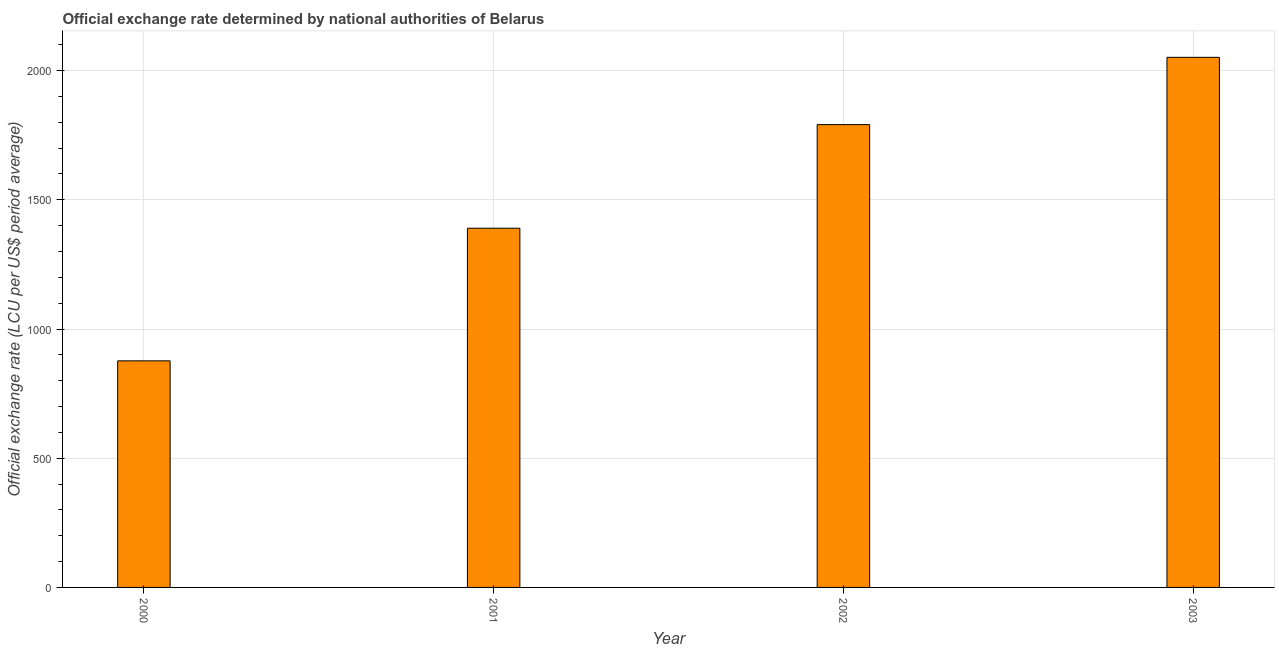Does the graph contain grids?
Offer a very short reply. Yes. What is the title of the graph?
Ensure brevity in your answer.  Official exchange rate determined by national authorities of Belarus. What is the label or title of the Y-axis?
Your answer should be very brief. Official exchange rate (LCU per US$ period average). What is the official exchange rate in 2003?
Your answer should be compact. 2051.27. Across all years, what is the maximum official exchange rate?
Provide a succinct answer. 2051.27. Across all years, what is the minimum official exchange rate?
Keep it short and to the point. 876.75. In which year was the official exchange rate maximum?
Your answer should be compact. 2003. In which year was the official exchange rate minimum?
Provide a succinct answer. 2000. What is the sum of the official exchange rate?
Ensure brevity in your answer.  6108.94. What is the difference between the official exchange rate in 2002 and 2003?
Provide a short and direct response. -260.35. What is the average official exchange rate per year?
Your response must be concise. 1527.23. What is the median official exchange rate?
Your answer should be compact. 1590.46. Do a majority of the years between 2002 and 2003 (inclusive) have official exchange rate greater than 1900 ?
Your response must be concise. No. What is the ratio of the official exchange rate in 2001 to that in 2002?
Your response must be concise. 0.78. What is the difference between the highest and the second highest official exchange rate?
Provide a short and direct response. 260.35. Is the sum of the official exchange rate in 2000 and 2001 greater than the maximum official exchange rate across all years?
Give a very brief answer. Yes. What is the difference between the highest and the lowest official exchange rate?
Your answer should be very brief. 1174.52. How many bars are there?
Provide a succinct answer. 4. How many years are there in the graph?
Offer a very short reply. 4. What is the Official exchange rate (LCU per US$ period average) in 2000?
Offer a very short reply. 876.75. What is the Official exchange rate (LCU per US$ period average) in 2001?
Ensure brevity in your answer.  1390. What is the Official exchange rate (LCU per US$ period average) of 2002?
Offer a very short reply. 1790.92. What is the Official exchange rate (LCU per US$ period average) of 2003?
Make the answer very short. 2051.27. What is the difference between the Official exchange rate (LCU per US$ period average) in 2000 and 2001?
Your answer should be compact. -513.25. What is the difference between the Official exchange rate (LCU per US$ period average) in 2000 and 2002?
Provide a succinct answer. -914.17. What is the difference between the Official exchange rate (LCU per US$ period average) in 2000 and 2003?
Your response must be concise. -1174.52. What is the difference between the Official exchange rate (LCU per US$ period average) in 2001 and 2002?
Your response must be concise. -400.92. What is the difference between the Official exchange rate (LCU per US$ period average) in 2001 and 2003?
Your response must be concise. -661.27. What is the difference between the Official exchange rate (LCU per US$ period average) in 2002 and 2003?
Ensure brevity in your answer.  -260.35. What is the ratio of the Official exchange rate (LCU per US$ period average) in 2000 to that in 2001?
Provide a short and direct response. 0.63. What is the ratio of the Official exchange rate (LCU per US$ period average) in 2000 to that in 2002?
Provide a short and direct response. 0.49. What is the ratio of the Official exchange rate (LCU per US$ period average) in 2000 to that in 2003?
Offer a very short reply. 0.43. What is the ratio of the Official exchange rate (LCU per US$ period average) in 2001 to that in 2002?
Your answer should be very brief. 0.78. What is the ratio of the Official exchange rate (LCU per US$ period average) in 2001 to that in 2003?
Your answer should be very brief. 0.68. What is the ratio of the Official exchange rate (LCU per US$ period average) in 2002 to that in 2003?
Keep it short and to the point. 0.87. 